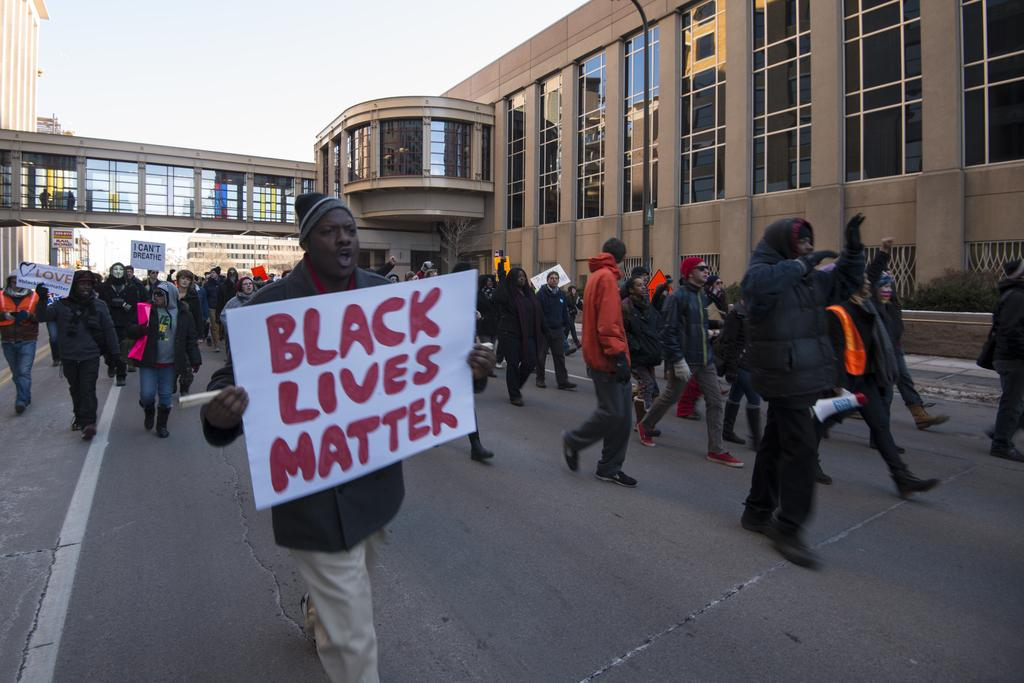What are the people in the image doing? The people in the image are walking on the street. What are the people holding while walking? The people are holding posters. What can be seen in the background of the image? There is a brown glass building in the background. What is visible at the top of the image? The sky is visible at the top of the image. What type of machine can be seen in the image? There is no machine present in the image. Is there a scarecrow standing among the people in the image? No, there is no scarecrow present in the image. 